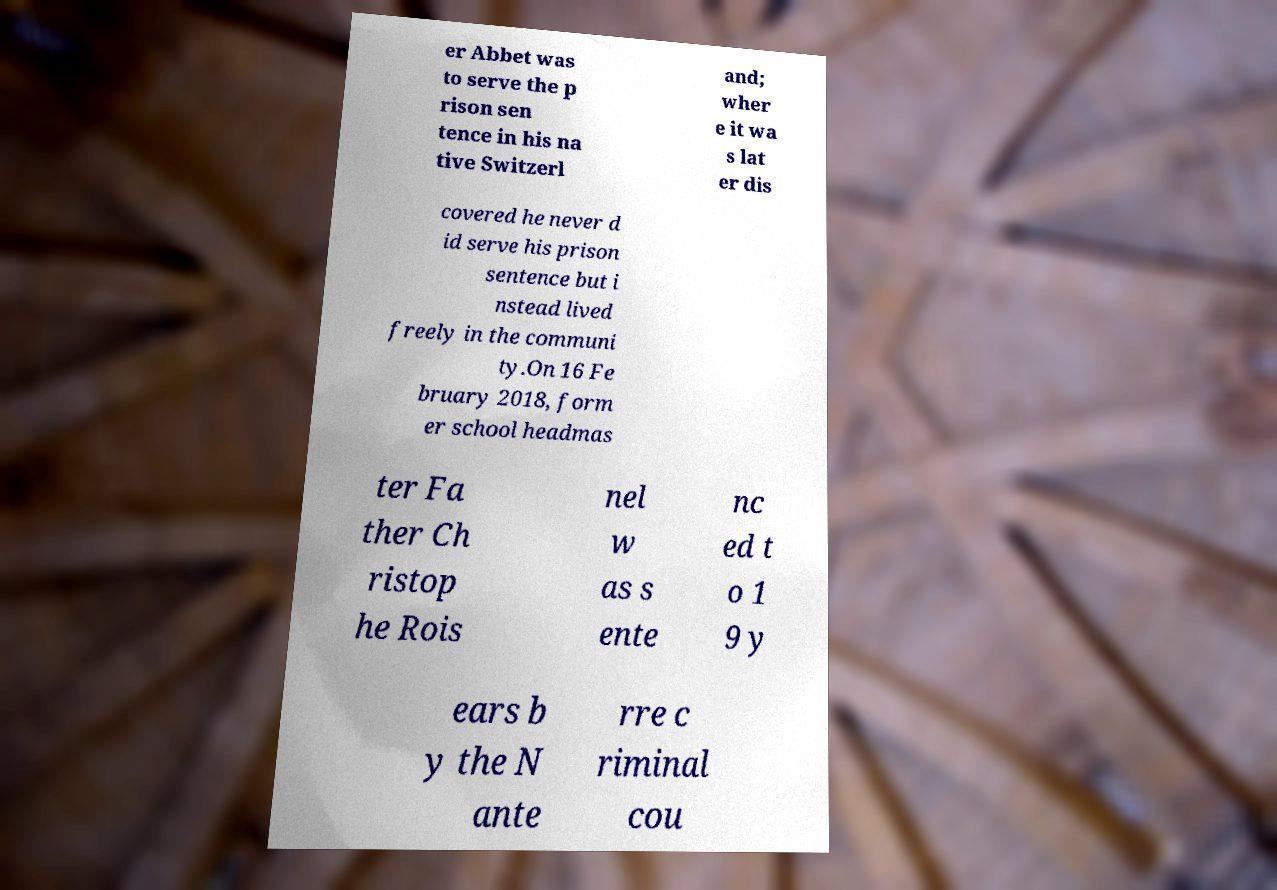What messages or text are displayed in this image? I need them in a readable, typed format. er Abbet was to serve the p rison sen tence in his na tive Switzerl and; wher e it wa s lat er dis covered he never d id serve his prison sentence but i nstead lived freely in the communi ty.On 16 Fe bruary 2018, form er school headmas ter Fa ther Ch ristop he Rois nel w as s ente nc ed t o 1 9 y ears b y the N ante rre c riminal cou 